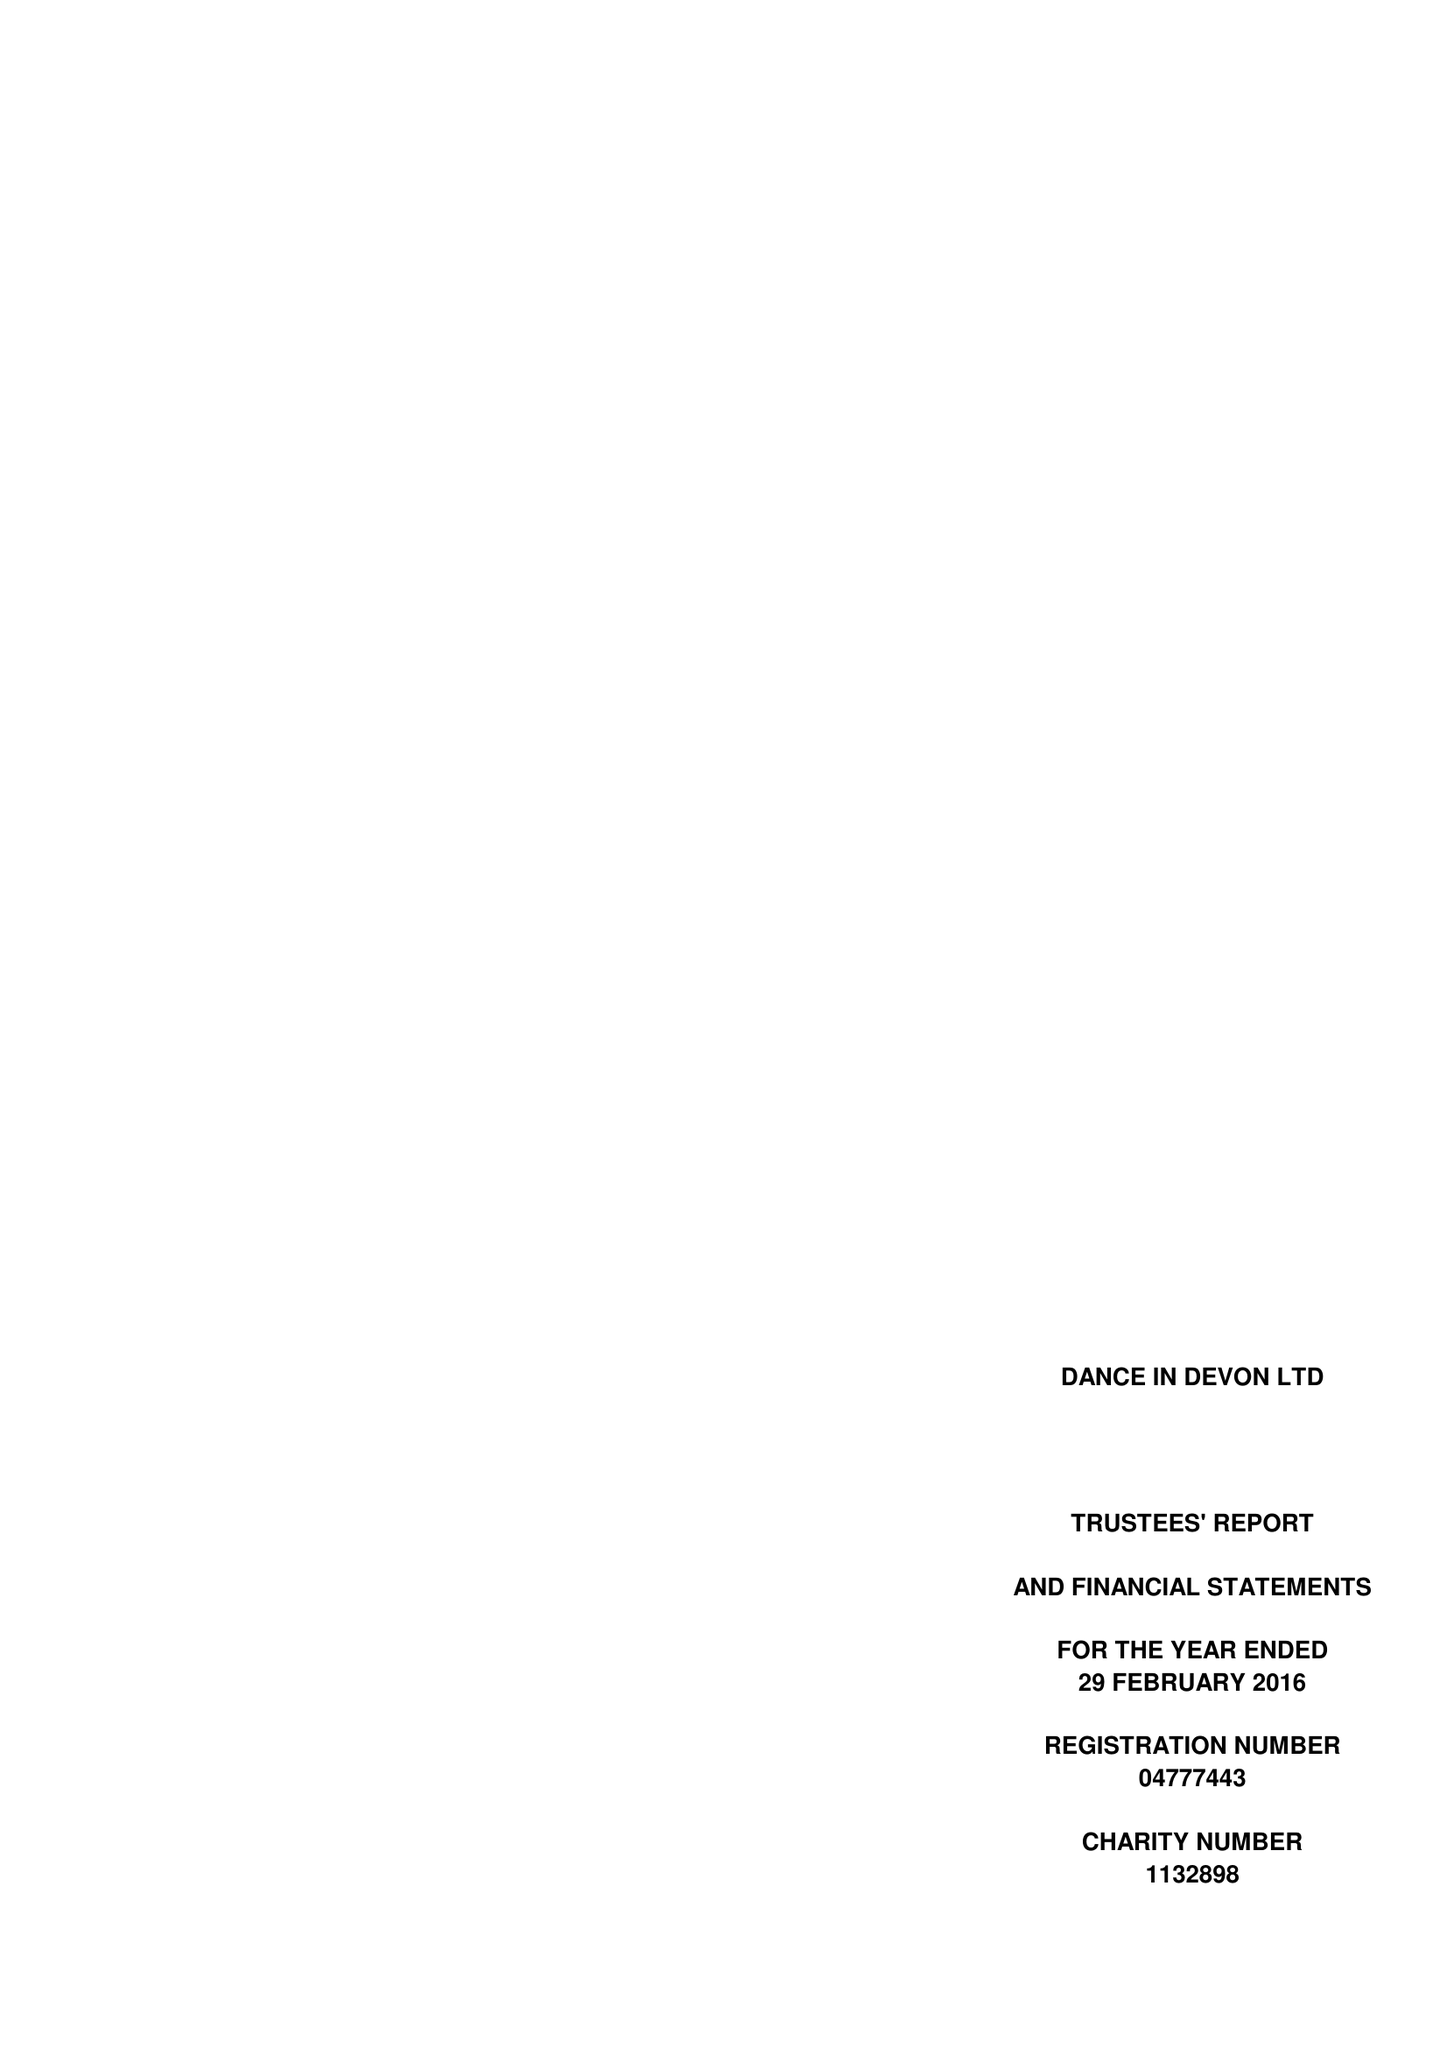What is the value for the address__post_town?
Answer the question using a single word or phrase. SOUTH BRENT 